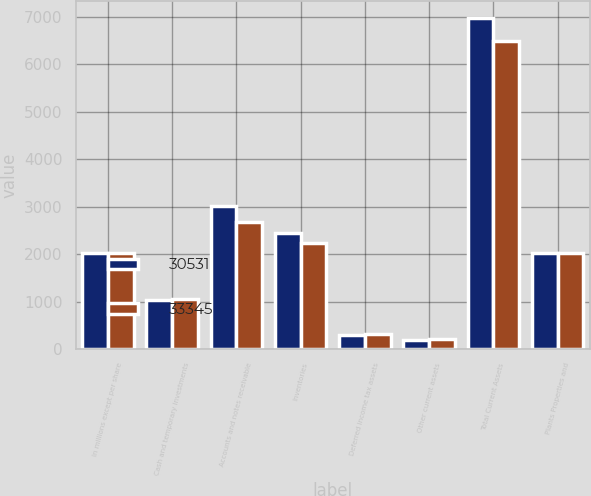<chart> <loc_0><loc_0><loc_500><loc_500><stacked_bar_chart><ecel><fcel>In millions except per share<fcel>Cash and temporary investments<fcel>Accounts and notes receivable<fcel>Inventories<fcel>Deferred income tax assets<fcel>Other current assets<fcel>Total Current Assets<fcel>Plants Properties and<nl><fcel>30531<fcel>2016<fcel>1033<fcel>3001<fcel>2438<fcel>299<fcel>198<fcel>6969<fcel>2015.5<nl><fcel>33345<fcel>2015<fcel>1050<fcel>2675<fcel>2228<fcel>312<fcel>212<fcel>6477<fcel>2015.5<nl></chart> 